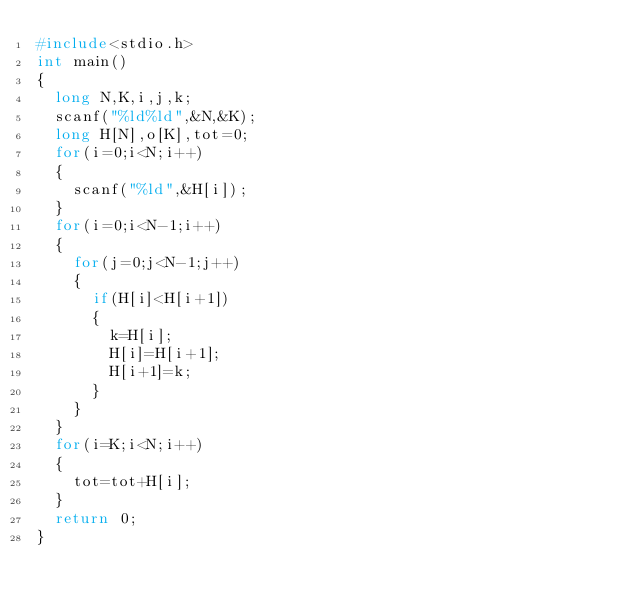Convert code to text. <code><loc_0><loc_0><loc_500><loc_500><_C_>#include<stdio.h>
int main()
{
  long N,K,i,j,k;
  scanf("%ld%ld",&N,&K);
  long H[N],o[K],tot=0;
  for(i=0;i<N;i++)
  {
    scanf("%ld",&H[i]);
  }
  for(i=0;i<N-1;i++)
  {
    for(j=0;j<N-1;j++)
    {
      if(H[i]<H[i+1])
      {  
        k=H[i];
        H[i]=H[i+1];
        H[i+1]=k;
      }
    }
  }
  for(i=K;i<N;i++)
  {
    tot=tot+H[i];
  }
  return 0;
}</code> 